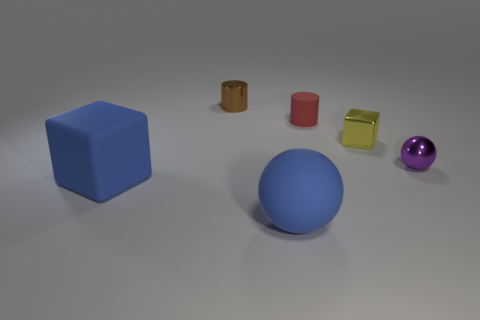There is a object that is both in front of the tiny metal ball and right of the large blue cube; what material is it made of?
Give a very brief answer. Rubber. What is the material of the ball that is in front of the purple thing?
Ensure brevity in your answer.  Rubber. What color is the cylinder that is the same material as the blue sphere?
Give a very brief answer. Red. There is a purple thing; is its shape the same as the big rubber object that is to the right of the metal cylinder?
Offer a very short reply. Yes. Are there any small metallic objects in front of the tiny yellow metallic thing?
Offer a very short reply. Yes. There is a brown cylinder; does it have the same size as the rubber thing left of the rubber ball?
Keep it short and to the point. No. Are there any things that have the same color as the large rubber ball?
Your answer should be compact. Yes. Are there any blue matte objects of the same shape as the small red matte thing?
Give a very brief answer. No. What shape is the object that is both left of the blue sphere and in front of the brown cylinder?
Your answer should be very brief. Cube. How many brown cylinders have the same material as the tiny purple object?
Ensure brevity in your answer.  1. 